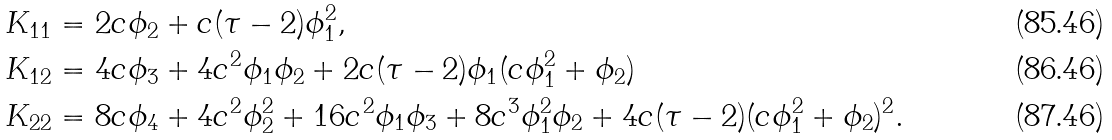<formula> <loc_0><loc_0><loc_500><loc_500>K _ { 1 1 } & = 2 c \phi _ { 2 } + c ( \tau - 2 ) \phi _ { 1 } ^ { 2 } , \\ K _ { 1 2 } & = 4 c \phi _ { 3 } + 4 c ^ { 2 } \phi _ { 1 } \phi _ { 2 } + 2 c ( \tau - 2 ) \phi _ { 1 } ( c \phi _ { 1 } ^ { 2 } + \phi _ { 2 } ) \\ K _ { 2 2 } & = 8 c \phi _ { 4 } + 4 c ^ { 2 } \phi _ { 2 } ^ { 2 } + 1 6 c ^ { 2 } \phi _ { 1 } \phi _ { 3 } + 8 c ^ { 3 } \phi _ { 1 } ^ { 2 } \phi _ { 2 } + 4 c ( \tau - 2 ) ( c \phi _ { 1 } ^ { 2 } + \phi _ { 2 } ) ^ { 2 } .</formula> 